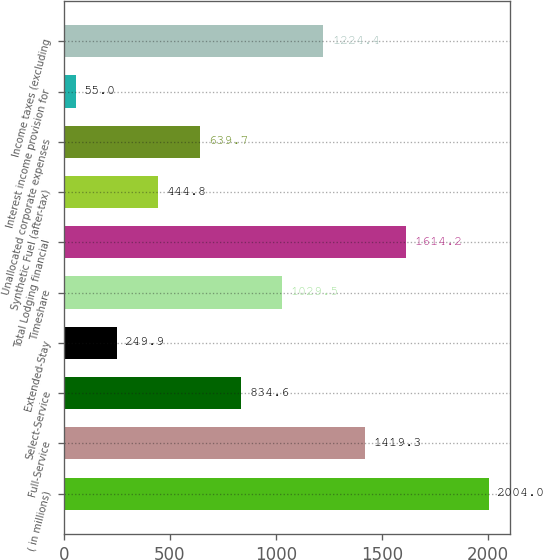Convert chart to OTSL. <chart><loc_0><loc_0><loc_500><loc_500><bar_chart><fcel>( in millions)<fcel>Full-Service<fcel>Select-Service<fcel>Extended-Stay<fcel>Timeshare<fcel>Total Lodging financial<fcel>Synthetic Fuel (after-tax)<fcel>Unallocated corporate expenses<fcel>Interest income provision for<fcel>Income taxes (excluding<nl><fcel>2004<fcel>1419.3<fcel>834.6<fcel>249.9<fcel>1029.5<fcel>1614.2<fcel>444.8<fcel>639.7<fcel>55<fcel>1224.4<nl></chart> 